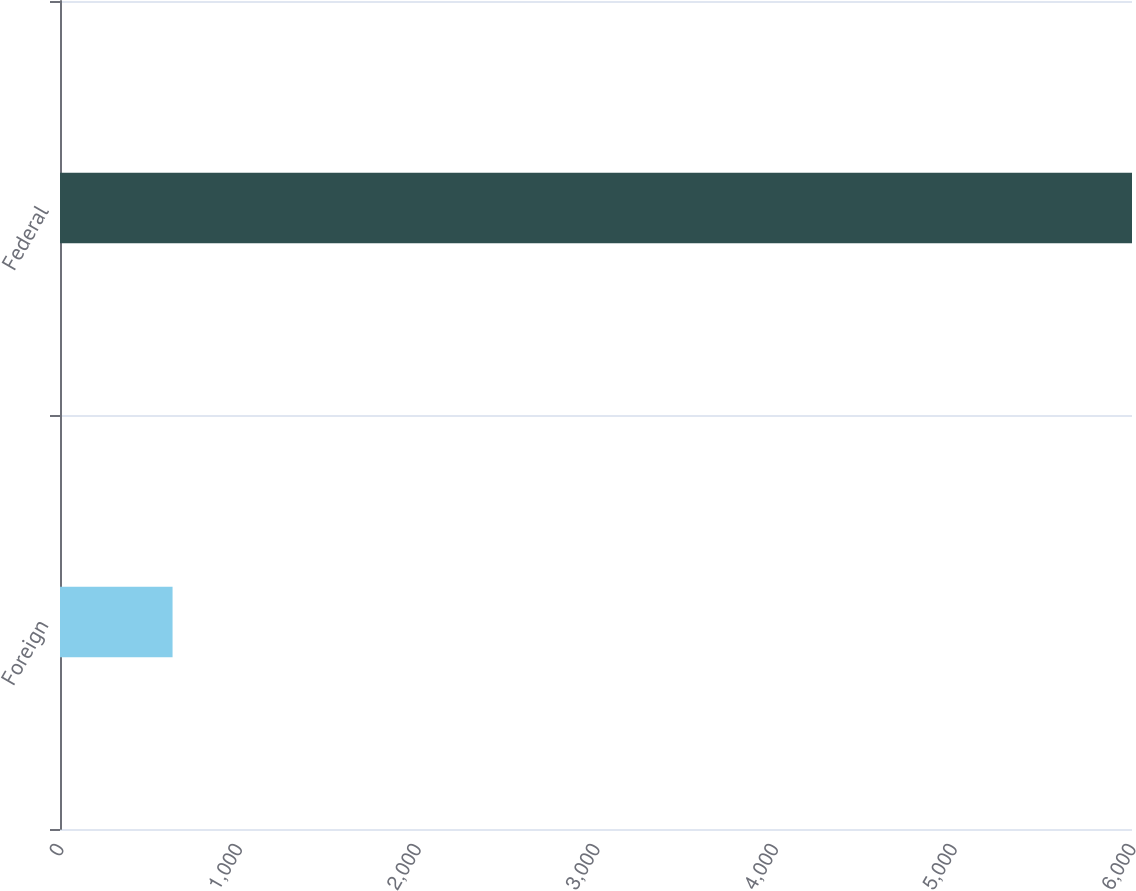<chart> <loc_0><loc_0><loc_500><loc_500><bar_chart><fcel>Foreign<fcel>Federal<nl><fcel>630<fcel>6000<nl></chart> 